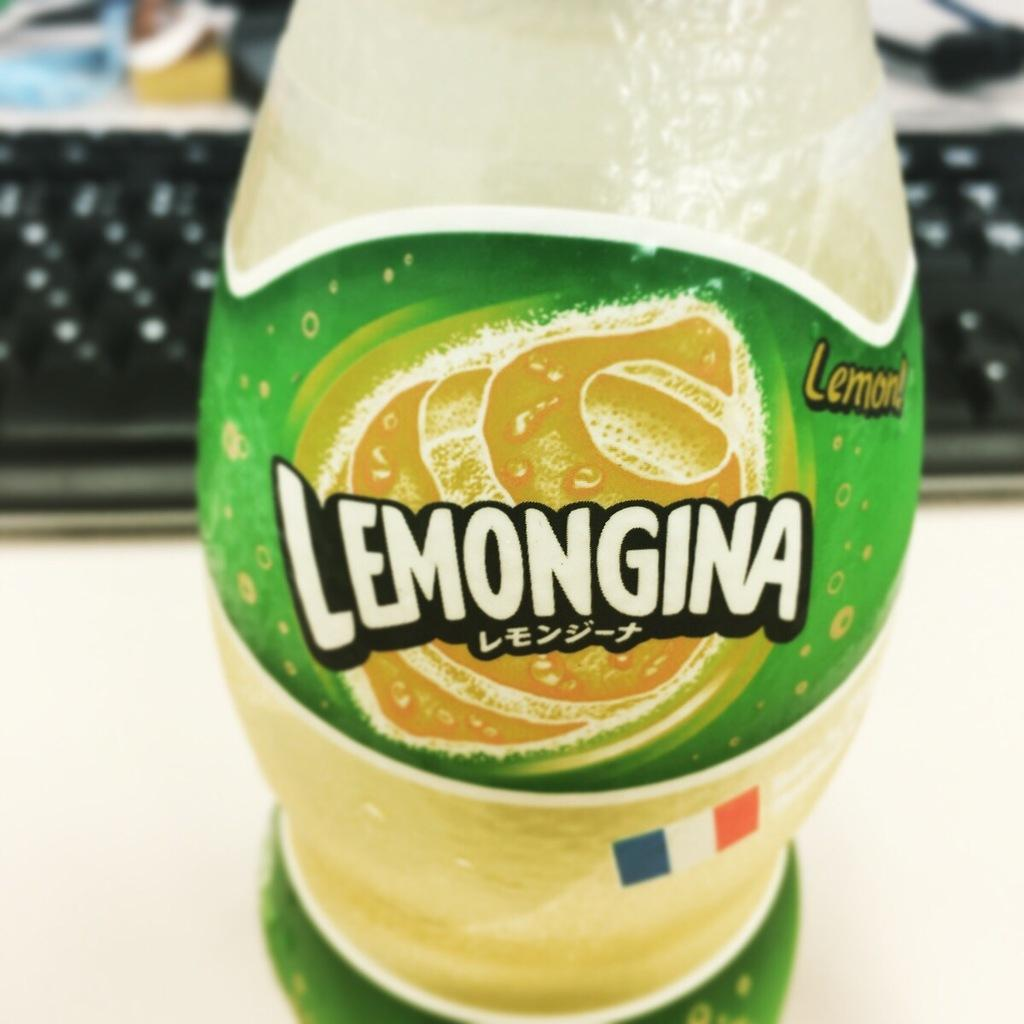What type of drink is shown in the image? There is a drink in the image, and it has a "Lemongina" label. Can you describe the label on the drink? The label on the drink says "Lemongina." What else is visible in the image besides the drink in the image? There is a keyboard visible at the back of the drink. How many buttons are on the skate in the image? There is no skate present in the image, so it is not possible to determine the number of buttons on a skate. 